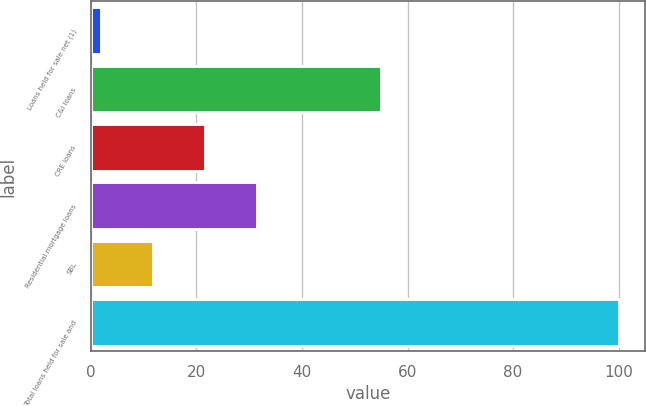Convert chart to OTSL. <chart><loc_0><loc_0><loc_500><loc_500><bar_chart><fcel>Loans held for sale net (1)<fcel>C&I loans<fcel>CRE loans<fcel>Residential mortgage loans<fcel>SBL<fcel>Total loans held for sale and<nl><fcel>2<fcel>55<fcel>21.6<fcel>31.4<fcel>11.8<fcel>100<nl></chart> 